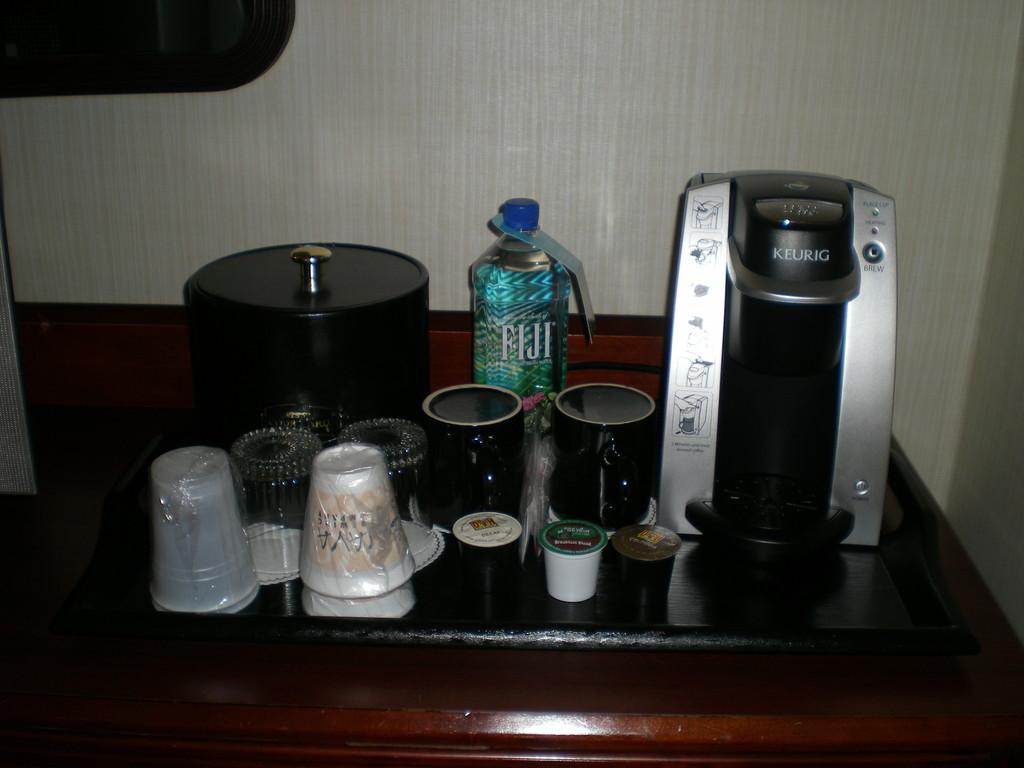<image>
Give a short and clear explanation of the subsequent image. A Keurig coffee maker sits next to mugs and a bottle of Fiji water. 